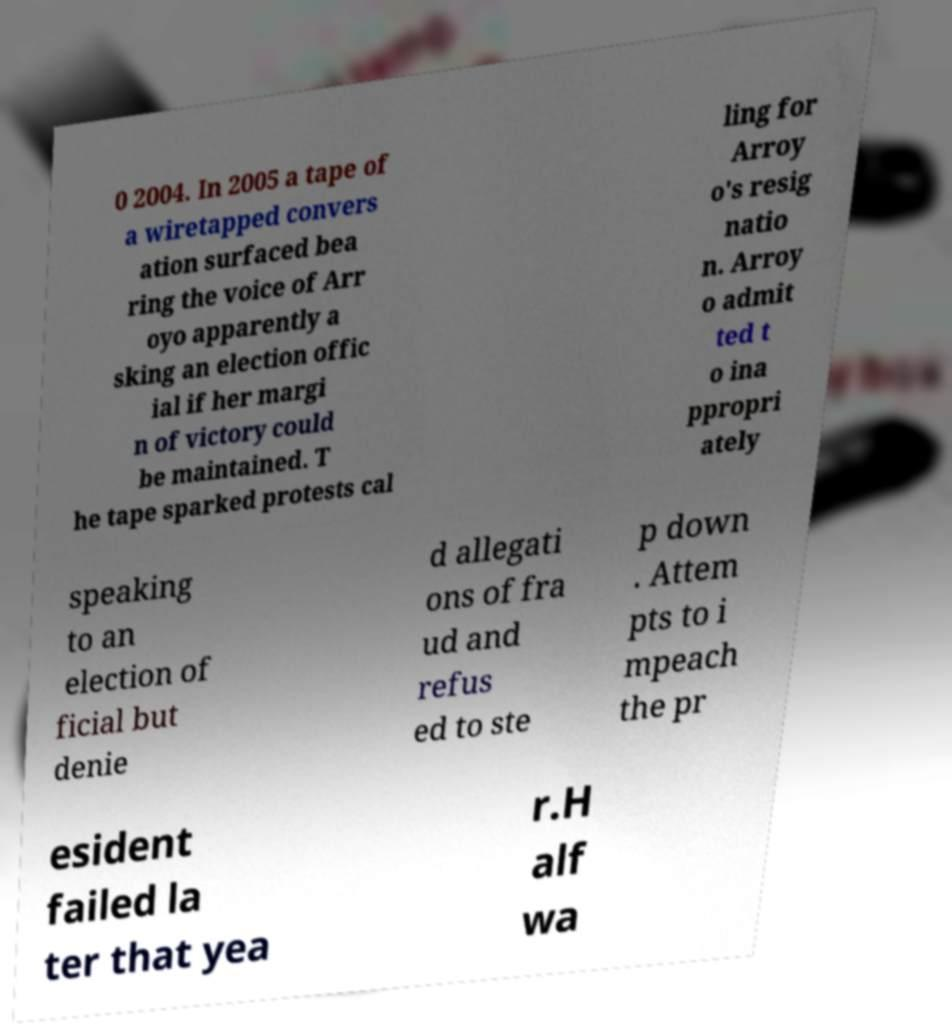Could you assist in decoding the text presented in this image and type it out clearly? 0 2004. In 2005 a tape of a wiretapped convers ation surfaced bea ring the voice of Arr oyo apparently a sking an election offic ial if her margi n of victory could be maintained. T he tape sparked protests cal ling for Arroy o's resig natio n. Arroy o admit ted t o ina ppropri ately speaking to an election of ficial but denie d allegati ons of fra ud and refus ed to ste p down . Attem pts to i mpeach the pr esident failed la ter that yea r.H alf wa 